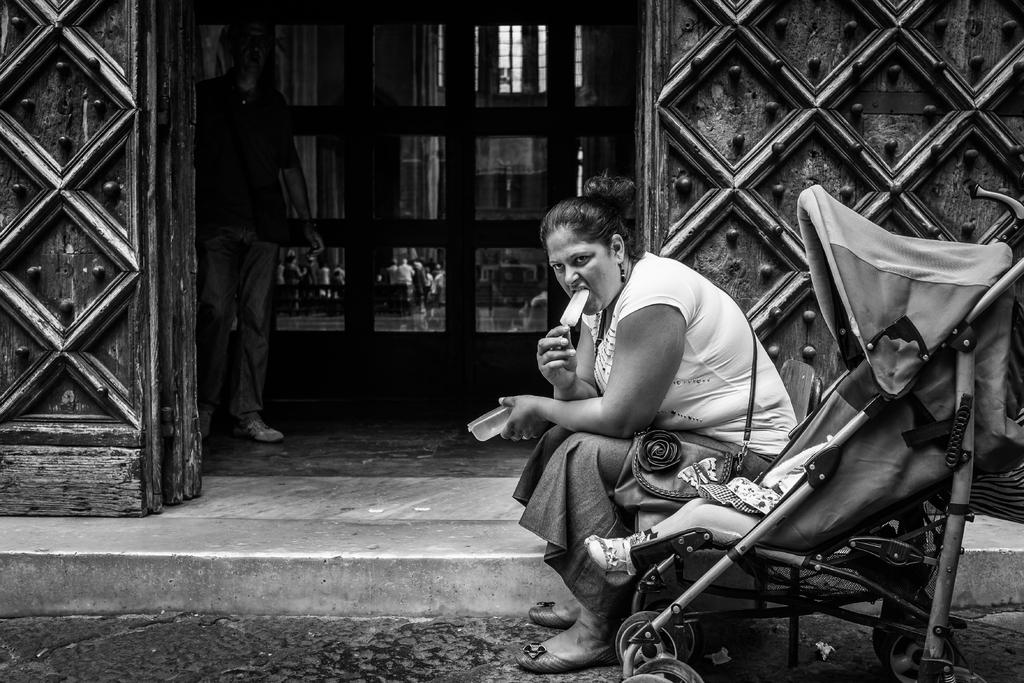Who is the main subject in the image? There is a lady in the image. Where is the lady located in the image? The lady is on the right side of the image. What is the lady doing in the image? The lady is eating an ice cream. What can be seen in the center of the image? There is a door in the center of the image. Can you see a goldfish swimming near the lady in the image? No, there is no goldfish present in the image. What time is it according to the watch the lady is wearing in the image? The lady is not wearing a watch in the image, so we cannot determine the time. 